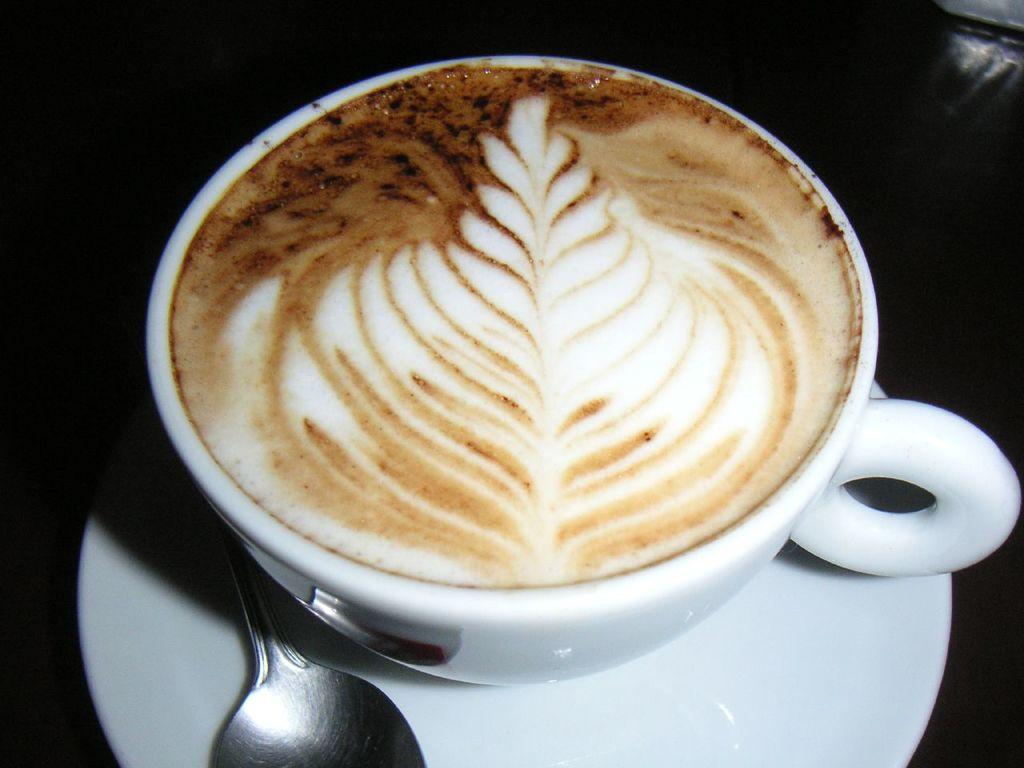What is the main object in the image? There is a coffee cup in the image. What is the coffee cup placed on? There is a saucer in the image. What utensil is present in the image? There is a spoon in the image. What can be said about the background of the image? The background of the image is dark. How many ladybugs can be seen crawling on the coffee cup in the image? There are no ladybugs present in the image. What type of agreement is being discussed in the image? There is no discussion or agreement depicted in the image; it only features a coffee cup, saucer, and spoon. 